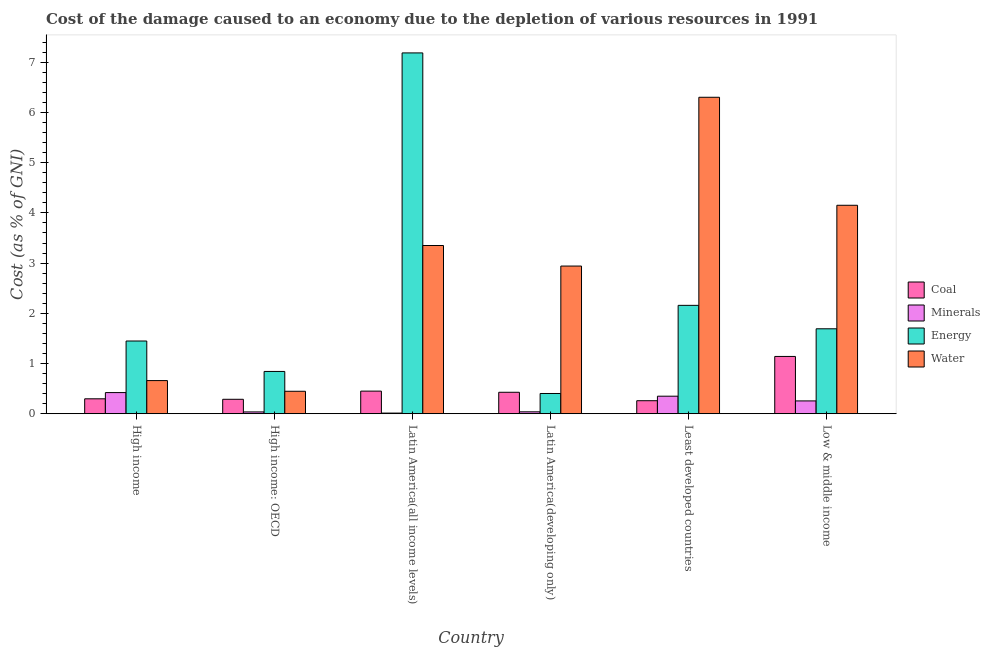Are the number of bars per tick equal to the number of legend labels?
Provide a succinct answer. Yes. How many bars are there on the 4th tick from the right?
Your answer should be very brief. 4. In how many cases, is the number of bars for a given country not equal to the number of legend labels?
Give a very brief answer. 0. What is the cost of damage due to depletion of energy in Least developed countries?
Give a very brief answer. 2.16. Across all countries, what is the maximum cost of damage due to depletion of minerals?
Keep it short and to the point. 0.42. Across all countries, what is the minimum cost of damage due to depletion of minerals?
Your answer should be compact. 0.01. In which country was the cost of damage due to depletion of coal maximum?
Offer a terse response. Low & middle income. In which country was the cost of damage due to depletion of water minimum?
Offer a very short reply. High income: OECD. What is the total cost of damage due to depletion of water in the graph?
Your answer should be very brief. 17.85. What is the difference between the cost of damage due to depletion of coal in High income: OECD and that in Latin America(developing only)?
Keep it short and to the point. -0.14. What is the difference between the cost of damage due to depletion of minerals in Low & middle income and the cost of damage due to depletion of water in Least developed countries?
Provide a short and direct response. -6.05. What is the average cost of damage due to depletion of energy per country?
Offer a very short reply. 2.29. What is the difference between the cost of damage due to depletion of coal and cost of damage due to depletion of energy in Latin America(all income levels)?
Provide a short and direct response. -6.73. What is the ratio of the cost of damage due to depletion of minerals in High income to that in Latin America(all income levels)?
Make the answer very short. 32.36. Is the cost of damage due to depletion of minerals in High income: OECD less than that in Low & middle income?
Ensure brevity in your answer.  Yes. What is the difference between the highest and the second highest cost of damage due to depletion of energy?
Ensure brevity in your answer.  5.03. What is the difference between the highest and the lowest cost of damage due to depletion of water?
Your response must be concise. 5.85. In how many countries, is the cost of damage due to depletion of water greater than the average cost of damage due to depletion of water taken over all countries?
Your answer should be compact. 3. Is it the case that in every country, the sum of the cost of damage due to depletion of energy and cost of damage due to depletion of minerals is greater than the sum of cost of damage due to depletion of water and cost of damage due to depletion of coal?
Give a very brief answer. Yes. What does the 3rd bar from the left in Low & middle income represents?
Give a very brief answer. Energy. What does the 1st bar from the right in Latin America(developing only) represents?
Ensure brevity in your answer.  Water. Is it the case that in every country, the sum of the cost of damage due to depletion of coal and cost of damage due to depletion of minerals is greater than the cost of damage due to depletion of energy?
Offer a very short reply. No. Are all the bars in the graph horizontal?
Offer a very short reply. No. Are the values on the major ticks of Y-axis written in scientific E-notation?
Your response must be concise. No. Does the graph contain any zero values?
Provide a succinct answer. No. Where does the legend appear in the graph?
Provide a succinct answer. Center right. How are the legend labels stacked?
Offer a very short reply. Vertical. What is the title of the graph?
Your response must be concise. Cost of the damage caused to an economy due to the depletion of various resources in 1991 . Does "Insurance services" appear as one of the legend labels in the graph?
Give a very brief answer. No. What is the label or title of the X-axis?
Offer a very short reply. Country. What is the label or title of the Y-axis?
Offer a terse response. Cost (as % of GNI). What is the Cost (as % of GNI) in Coal in High income?
Keep it short and to the point. 0.3. What is the Cost (as % of GNI) of Minerals in High income?
Keep it short and to the point. 0.42. What is the Cost (as % of GNI) of Energy in High income?
Make the answer very short. 1.45. What is the Cost (as % of GNI) of Water in High income?
Your answer should be very brief. 0.66. What is the Cost (as % of GNI) of Coal in High income: OECD?
Make the answer very short. 0.29. What is the Cost (as % of GNI) of Minerals in High income: OECD?
Your answer should be very brief. 0.04. What is the Cost (as % of GNI) in Energy in High income: OECD?
Offer a terse response. 0.84. What is the Cost (as % of GNI) in Water in High income: OECD?
Your answer should be very brief. 0.45. What is the Cost (as % of GNI) in Coal in Latin America(all income levels)?
Ensure brevity in your answer.  0.45. What is the Cost (as % of GNI) in Minerals in Latin America(all income levels)?
Provide a succinct answer. 0.01. What is the Cost (as % of GNI) in Energy in Latin America(all income levels)?
Provide a succinct answer. 7.19. What is the Cost (as % of GNI) in Water in Latin America(all income levels)?
Offer a terse response. 3.35. What is the Cost (as % of GNI) in Coal in Latin America(developing only)?
Your answer should be compact. 0.43. What is the Cost (as % of GNI) of Minerals in Latin America(developing only)?
Make the answer very short. 0.04. What is the Cost (as % of GNI) in Energy in Latin America(developing only)?
Provide a succinct answer. 0.4. What is the Cost (as % of GNI) of Water in Latin America(developing only)?
Your answer should be compact. 2.94. What is the Cost (as % of GNI) in Coal in Least developed countries?
Offer a terse response. 0.26. What is the Cost (as % of GNI) in Minerals in Least developed countries?
Provide a succinct answer. 0.35. What is the Cost (as % of GNI) of Energy in Least developed countries?
Offer a terse response. 2.16. What is the Cost (as % of GNI) in Water in Least developed countries?
Provide a short and direct response. 6.3. What is the Cost (as % of GNI) of Coal in Low & middle income?
Keep it short and to the point. 1.14. What is the Cost (as % of GNI) of Minerals in Low & middle income?
Offer a terse response. 0.26. What is the Cost (as % of GNI) of Energy in Low & middle income?
Your answer should be very brief. 1.69. What is the Cost (as % of GNI) of Water in Low & middle income?
Offer a very short reply. 4.15. Across all countries, what is the maximum Cost (as % of GNI) of Coal?
Offer a terse response. 1.14. Across all countries, what is the maximum Cost (as % of GNI) of Minerals?
Your answer should be very brief. 0.42. Across all countries, what is the maximum Cost (as % of GNI) of Energy?
Provide a succinct answer. 7.19. Across all countries, what is the maximum Cost (as % of GNI) in Water?
Offer a very short reply. 6.3. Across all countries, what is the minimum Cost (as % of GNI) of Coal?
Offer a very short reply. 0.26. Across all countries, what is the minimum Cost (as % of GNI) in Minerals?
Offer a terse response. 0.01. Across all countries, what is the minimum Cost (as % of GNI) of Energy?
Your answer should be very brief. 0.4. Across all countries, what is the minimum Cost (as % of GNI) in Water?
Ensure brevity in your answer.  0.45. What is the total Cost (as % of GNI) in Coal in the graph?
Make the answer very short. 2.86. What is the total Cost (as % of GNI) in Minerals in the graph?
Offer a terse response. 1.11. What is the total Cost (as % of GNI) of Energy in the graph?
Give a very brief answer. 13.73. What is the total Cost (as % of GNI) of Water in the graph?
Your answer should be compact. 17.85. What is the difference between the Cost (as % of GNI) of Coal in High income and that in High income: OECD?
Ensure brevity in your answer.  0.01. What is the difference between the Cost (as % of GNI) in Minerals in High income and that in High income: OECD?
Make the answer very short. 0.38. What is the difference between the Cost (as % of GNI) of Energy in High income and that in High income: OECD?
Keep it short and to the point. 0.61. What is the difference between the Cost (as % of GNI) of Water in High income and that in High income: OECD?
Give a very brief answer. 0.21. What is the difference between the Cost (as % of GNI) in Coal in High income and that in Latin America(all income levels)?
Your response must be concise. -0.15. What is the difference between the Cost (as % of GNI) of Minerals in High income and that in Latin America(all income levels)?
Your answer should be very brief. 0.41. What is the difference between the Cost (as % of GNI) of Energy in High income and that in Latin America(all income levels)?
Keep it short and to the point. -5.74. What is the difference between the Cost (as % of GNI) of Water in High income and that in Latin America(all income levels)?
Keep it short and to the point. -2.69. What is the difference between the Cost (as % of GNI) in Coal in High income and that in Latin America(developing only)?
Keep it short and to the point. -0.13. What is the difference between the Cost (as % of GNI) in Minerals in High income and that in Latin America(developing only)?
Your answer should be very brief. 0.38. What is the difference between the Cost (as % of GNI) in Energy in High income and that in Latin America(developing only)?
Give a very brief answer. 1.05. What is the difference between the Cost (as % of GNI) in Water in High income and that in Latin America(developing only)?
Provide a succinct answer. -2.28. What is the difference between the Cost (as % of GNI) in Coal in High income and that in Least developed countries?
Offer a terse response. 0.04. What is the difference between the Cost (as % of GNI) of Minerals in High income and that in Least developed countries?
Your answer should be very brief. 0.07. What is the difference between the Cost (as % of GNI) of Energy in High income and that in Least developed countries?
Ensure brevity in your answer.  -0.71. What is the difference between the Cost (as % of GNI) in Water in High income and that in Least developed countries?
Ensure brevity in your answer.  -5.64. What is the difference between the Cost (as % of GNI) in Coal in High income and that in Low & middle income?
Give a very brief answer. -0.84. What is the difference between the Cost (as % of GNI) of Minerals in High income and that in Low & middle income?
Your response must be concise. 0.17. What is the difference between the Cost (as % of GNI) in Energy in High income and that in Low & middle income?
Provide a short and direct response. -0.24. What is the difference between the Cost (as % of GNI) of Water in High income and that in Low & middle income?
Your answer should be very brief. -3.49. What is the difference between the Cost (as % of GNI) in Coal in High income: OECD and that in Latin America(all income levels)?
Your response must be concise. -0.16. What is the difference between the Cost (as % of GNI) in Minerals in High income: OECD and that in Latin America(all income levels)?
Make the answer very short. 0.02. What is the difference between the Cost (as % of GNI) of Energy in High income: OECD and that in Latin America(all income levels)?
Your response must be concise. -6.34. What is the difference between the Cost (as % of GNI) in Water in High income: OECD and that in Latin America(all income levels)?
Make the answer very short. -2.9. What is the difference between the Cost (as % of GNI) in Coal in High income: OECD and that in Latin America(developing only)?
Your answer should be compact. -0.14. What is the difference between the Cost (as % of GNI) of Minerals in High income: OECD and that in Latin America(developing only)?
Provide a short and direct response. -0. What is the difference between the Cost (as % of GNI) in Energy in High income: OECD and that in Latin America(developing only)?
Your answer should be very brief. 0.44. What is the difference between the Cost (as % of GNI) of Water in High income: OECD and that in Latin America(developing only)?
Your answer should be very brief. -2.49. What is the difference between the Cost (as % of GNI) of Coal in High income: OECD and that in Least developed countries?
Your answer should be compact. 0.03. What is the difference between the Cost (as % of GNI) in Minerals in High income: OECD and that in Least developed countries?
Give a very brief answer. -0.31. What is the difference between the Cost (as % of GNI) of Energy in High income: OECD and that in Least developed countries?
Provide a succinct answer. -1.32. What is the difference between the Cost (as % of GNI) in Water in High income: OECD and that in Least developed countries?
Your response must be concise. -5.85. What is the difference between the Cost (as % of GNI) of Coal in High income: OECD and that in Low & middle income?
Give a very brief answer. -0.85. What is the difference between the Cost (as % of GNI) of Minerals in High income: OECD and that in Low & middle income?
Your response must be concise. -0.22. What is the difference between the Cost (as % of GNI) in Energy in High income: OECD and that in Low & middle income?
Provide a succinct answer. -0.85. What is the difference between the Cost (as % of GNI) of Water in High income: OECD and that in Low & middle income?
Your answer should be compact. -3.7. What is the difference between the Cost (as % of GNI) of Coal in Latin America(all income levels) and that in Latin America(developing only)?
Ensure brevity in your answer.  0.02. What is the difference between the Cost (as % of GNI) in Minerals in Latin America(all income levels) and that in Latin America(developing only)?
Provide a succinct answer. -0.03. What is the difference between the Cost (as % of GNI) in Energy in Latin America(all income levels) and that in Latin America(developing only)?
Your answer should be very brief. 6.78. What is the difference between the Cost (as % of GNI) of Water in Latin America(all income levels) and that in Latin America(developing only)?
Your answer should be compact. 0.41. What is the difference between the Cost (as % of GNI) in Coal in Latin America(all income levels) and that in Least developed countries?
Give a very brief answer. 0.19. What is the difference between the Cost (as % of GNI) of Minerals in Latin America(all income levels) and that in Least developed countries?
Give a very brief answer. -0.34. What is the difference between the Cost (as % of GNI) in Energy in Latin America(all income levels) and that in Least developed countries?
Provide a succinct answer. 5.03. What is the difference between the Cost (as % of GNI) of Water in Latin America(all income levels) and that in Least developed countries?
Your answer should be very brief. -2.95. What is the difference between the Cost (as % of GNI) in Coal in Latin America(all income levels) and that in Low & middle income?
Offer a terse response. -0.69. What is the difference between the Cost (as % of GNI) in Minerals in Latin America(all income levels) and that in Low & middle income?
Give a very brief answer. -0.24. What is the difference between the Cost (as % of GNI) in Energy in Latin America(all income levels) and that in Low & middle income?
Give a very brief answer. 5.49. What is the difference between the Cost (as % of GNI) of Water in Latin America(all income levels) and that in Low & middle income?
Your answer should be compact. -0.8. What is the difference between the Cost (as % of GNI) in Coal in Latin America(developing only) and that in Least developed countries?
Keep it short and to the point. 0.17. What is the difference between the Cost (as % of GNI) of Minerals in Latin America(developing only) and that in Least developed countries?
Offer a very short reply. -0.31. What is the difference between the Cost (as % of GNI) in Energy in Latin America(developing only) and that in Least developed countries?
Provide a short and direct response. -1.76. What is the difference between the Cost (as % of GNI) in Water in Latin America(developing only) and that in Least developed countries?
Offer a very short reply. -3.36. What is the difference between the Cost (as % of GNI) of Coal in Latin America(developing only) and that in Low & middle income?
Your answer should be compact. -0.71. What is the difference between the Cost (as % of GNI) in Minerals in Latin America(developing only) and that in Low & middle income?
Offer a very short reply. -0.22. What is the difference between the Cost (as % of GNI) in Energy in Latin America(developing only) and that in Low & middle income?
Your response must be concise. -1.29. What is the difference between the Cost (as % of GNI) of Water in Latin America(developing only) and that in Low & middle income?
Ensure brevity in your answer.  -1.21. What is the difference between the Cost (as % of GNI) in Coal in Least developed countries and that in Low & middle income?
Make the answer very short. -0.88. What is the difference between the Cost (as % of GNI) of Minerals in Least developed countries and that in Low & middle income?
Offer a very short reply. 0.09. What is the difference between the Cost (as % of GNI) of Energy in Least developed countries and that in Low & middle income?
Offer a very short reply. 0.47. What is the difference between the Cost (as % of GNI) in Water in Least developed countries and that in Low & middle income?
Your answer should be very brief. 2.15. What is the difference between the Cost (as % of GNI) of Coal in High income and the Cost (as % of GNI) of Minerals in High income: OECD?
Make the answer very short. 0.26. What is the difference between the Cost (as % of GNI) of Coal in High income and the Cost (as % of GNI) of Energy in High income: OECD?
Provide a succinct answer. -0.55. What is the difference between the Cost (as % of GNI) in Coal in High income and the Cost (as % of GNI) in Water in High income: OECD?
Ensure brevity in your answer.  -0.15. What is the difference between the Cost (as % of GNI) of Minerals in High income and the Cost (as % of GNI) of Energy in High income: OECD?
Your answer should be very brief. -0.42. What is the difference between the Cost (as % of GNI) in Minerals in High income and the Cost (as % of GNI) in Water in High income: OECD?
Your answer should be very brief. -0.03. What is the difference between the Cost (as % of GNI) of Coal in High income and the Cost (as % of GNI) of Minerals in Latin America(all income levels)?
Give a very brief answer. 0.28. What is the difference between the Cost (as % of GNI) of Coal in High income and the Cost (as % of GNI) of Energy in Latin America(all income levels)?
Offer a terse response. -6.89. What is the difference between the Cost (as % of GNI) in Coal in High income and the Cost (as % of GNI) in Water in Latin America(all income levels)?
Offer a very short reply. -3.05. What is the difference between the Cost (as % of GNI) of Minerals in High income and the Cost (as % of GNI) of Energy in Latin America(all income levels)?
Your answer should be compact. -6.76. What is the difference between the Cost (as % of GNI) of Minerals in High income and the Cost (as % of GNI) of Water in Latin America(all income levels)?
Keep it short and to the point. -2.93. What is the difference between the Cost (as % of GNI) of Energy in High income and the Cost (as % of GNI) of Water in Latin America(all income levels)?
Your answer should be very brief. -1.9. What is the difference between the Cost (as % of GNI) of Coal in High income and the Cost (as % of GNI) of Minerals in Latin America(developing only)?
Give a very brief answer. 0.26. What is the difference between the Cost (as % of GNI) in Coal in High income and the Cost (as % of GNI) in Energy in Latin America(developing only)?
Your answer should be very brief. -0.11. What is the difference between the Cost (as % of GNI) of Coal in High income and the Cost (as % of GNI) of Water in Latin America(developing only)?
Offer a very short reply. -2.64. What is the difference between the Cost (as % of GNI) in Minerals in High income and the Cost (as % of GNI) in Energy in Latin America(developing only)?
Your response must be concise. 0.02. What is the difference between the Cost (as % of GNI) of Minerals in High income and the Cost (as % of GNI) of Water in Latin America(developing only)?
Your answer should be very brief. -2.52. What is the difference between the Cost (as % of GNI) in Energy in High income and the Cost (as % of GNI) in Water in Latin America(developing only)?
Your answer should be very brief. -1.49. What is the difference between the Cost (as % of GNI) of Coal in High income and the Cost (as % of GNI) of Minerals in Least developed countries?
Provide a succinct answer. -0.05. What is the difference between the Cost (as % of GNI) in Coal in High income and the Cost (as % of GNI) in Energy in Least developed countries?
Your response must be concise. -1.86. What is the difference between the Cost (as % of GNI) of Coal in High income and the Cost (as % of GNI) of Water in Least developed countries?
Provide a succinct answer. -6. What is the difference between the Cost (as % of GNI) of Minerals in High income and the Cost (as % of GNI) of Energy in Least developed countries?
Offer a terse response. -1.74. What is the difference between the Cost (as % of GNI) of Minerals in High income and the Cost (as % of GNI) of Water in Least developed countries?
Your response must be concise. -5.88. What is the difference between the Cost (as % of GNI) of Energy in High income and the Cost (as % of GNI) of Water in Least developed countries?
Offer a very short reply. -4.85. What is the difference between the Cost (as % of GNI) in Coal in High income and the Cost (as % of GNI) in Minerals in Low & middle income?
Make the answer very short. 0.04. What is the difference between the Cost (as % of GNI) in Coal in High income and the Cost (as % of GNI) in Energy in Low & middle income?
Make the answer very short. -1.39. What is the difference between the Cost (as % of GNI) of Coal in High income and the Cost (as % of GNI) of Water in Low & middle income?
Your answer should be very brief. -3.85. What is the difference between the Cost (as % of GNI) of Minerals in High income and the Cost (as % of GNI) of Energy in Low & middle income?
Offer a very short reply. -1.27. What is the difference between the Cost (as % of GNI) of Minerals in High income and the Cost (as % of GNI) of Water in Low & middle income?
Make the answer very short. -3.73. What is the difference between the Cost (as % of GNI) in Energy in High income and the Cost (as % of GNI) in Water in Low & middle income?
Offer a very short reply. -2.7. What is the difference between the Cost (as % of GNI) in Coal in High income: OECD and the Cost (as % of GNI) in Minerals in Latin America(all income levels)?
Make the answer very short. 0.27. What is the difference between the Cost (as % of GNI) in Coal in High income: OECD and the Cost (as % of GNI) in Energy in Latin America(all income levels)?
Provide a succinct answer. -6.9. What is the difference between the Cost (as % of GNI) in Coal in High income: OECD and the Cost (as % of GNI) in Water in Latin America(all income levels)?
Offer a very short reply. -3.06. What is the difference between the Cost (as % of GNI) of Minerals in High income: OECD and the Cost (as % of GNI) of Energy in Latin America(all income levels)?
Provide a succinct answer. -7.15. What is the difference between the Cost (as % of GNI) in Minerals in High income: OECD and the Cost (as % of GNI) in Water in Latin America(all income levels)?
Give a very brief answer. -3.31. What is the difference between the Cost (as % of GNI) of Energy in High income: OECD and the Cost (as % of GNI) of Water in Latin America(all income levels)?
Ensure brevity in your answer.  -2.51. What is the difference between the Cost (as % of GNI) of Coal in High income: OECD and the Cost (as % of GNI) of Minerals in Latin America(developing only)?
Give a very brief answer. 0.25. What is the difference between the Cost (as % of GNI) in Coal in High income: OECD and the Cost (as % of GNI) in Energy in Latin America(developing only)?
Your answer should be very brief. -0.12. What is the difference between the Cost (as % of GNI) of Coal in High income: OECD and the Cost (as % of GNI) of Water in Latin America(developing only)?
Provide a succinct answer. -2.65. What is the difference between the Cost (as % of GNI) of Minerals in High income: OECD and the Cost (as % of GNI) of Energy in Latin America(developing only)?
Your answer should be very brief. -0.37. What is the difference between the Cost (as % of GNI) in Minerals in High income: OECD and the Cost (as % of GNI) in Water in Latin America(developing only)?
Keep it short and to the point. -2.9. What is the difference between the Cost (as % of GNI) in Energy in High income: OECD and the Cost (as % of GNI) in Water in Latin America(developing only)?
Keep it short and to the point. -2.1. What is the difference between the Cost (as % of GNI) in Coal in High income: OECD and the Cost (as % of GNI) in Minerals in Least developed countries?
Your answer should be compact. -0.06. What is the difference between the Cost (as % of GNI) of Coal in High income: OECD and the Cost (as % of GNI) of Energy in Least developed countries?
Provide a short and direct response. -1.87. What is the difference between the Cost (as % of GNI) in Coal in High income: OECD and the Cost (as % of GNI) in Water in Least developed countries?
Offer a terse response. -6.01. What is the difference between the Cost (as % of GNI) in Minerals in High income: OECD and the Cost (as % of GNI) in Energy in Least developed countries?
Your response must be concise. -2.12. What is the difference between the Cost (as % of GNI) of Minerals in High income: OECD and the Cost (as % of GNI) of Water in Least developed countries?
Your answer should be very brief. -6.27. What is the difference between the Cost (as % of GNI) of Energy in High income: OECD and the Cost (as % of GNI) of Water in Least developed countries?
Your answer should be compact. -5.46. What is the difference between the Cost (as % of GNI) in Coal in High income: OECD and the Cost (as % of GNI) in Minerals in Low & middle income?
Keep it short and to the point. 0.03. What is the difference between the Cost (as % of GNI) of Coal in High income: OECD and the Cost (as % of GNI) of Energy in Low & middle income?
Provide a succinct answer. -1.4. What is the difference between the Cost (as % of GNI) in Coal in High income: OECD and the Cost (as % of GNI) in Water in Low & middle income?
Provide a succinct answer. -3.86. What is the difference between the Cost (as % of GNI) of Minerals in High income: OECD and the Cost (as % of GNI) of Energy in Low & middle income?
Your answer should be compact. -1.66. What is the difference between the Cost (as % of GNI) in Minerals in High income: OECD and the Cost (as % of GNI) in Water in Low & middle income?
Offer a terse response. -4.11. What is the difference between the Cost (as % of GNI) in Energy in High income: OECD and the Cost (as % of GNI) in Water in Low & middle income?
Your answer should be compact. -3.31. What is the difference between the Cost (as % of GNI) of Coal in Latin America(all income levels) and the Cost (as % of GNI) of Minerals in Latin America(developing only)?
Make the answer very short. 0.41. What is the difference between the Cost (as % of GNI) of Coal in Latin America(all income levels) and the Cost (as % of GNI) of Energy in Latin America(developing only)?
Provide a short and direct response. 0.05. What is the difference between the Cost (as % of GNI) in Coal in Latin America(all income levels) and the Cost (as % of GNI) in Water in Latin America(developing only)?
Keep it short and to the point. -2.49. What is the difference between the Cost (as % of GNI) of Minerals in Latin America(all income levels) and the Cost (as % of GNI) of Energy in Latin America(developing only)?
Your response must be concise. -0.39. What is the difference between the Cost (as % of GNI) in Minerals in Latin America(all income levels) and the Cost (as % of GNI) in Water in Latin America(developing only)?
Offer a terse response. -2.93. What is the difference between the Cost (as % of GNI) of Energy in Latin America(all income levels) and the Cost (as % of GNI) of Water in Latin America(developing only)?
Make the answer very short. 4.24. What is the difference between the Cost (as % of GNI) of Coal in Latin America(all income levels) and the Cost (as % of GNI) of Minerals in Least developed countries?
Your answer should be compact. 0.1. What is the difference between the Cost (as % of GNI) of Coal in Latin America(all income levels) and the Cost (as % of GNI) of Energy in Least developed countries?
Your answer should be compact. -1.71. What is the difference between the Cost (as % of GNI) of Coal in Latin America(all income levels) and the Cost (as % of GNI) of Water in Least developed countries?
Your answer should be compact. -5.85. What is the difference between the Cost (as % of GNI) of Minerals in Latin America(all income levels) and the Cost (as % of GNI) of Energy in Least developed countries?
Give a very brief answer. -2.15. What is the difference between the Cost (as % of GNI) in Minerals in Latin America(all income levels) and the Cost (as % of GNI) in Water in Least developed countries?
Offer a terse response. -6.29. What is the difference between the Cost (as % of GNI) in Energy in Latin America(all income levels) and the Cost (as % of GNI) in Water in Least developed countries?
Your answer should be compact. 0.88. What is the difference between the Cost (as % of GNI) of Coal in Latin America(all income levels) and the Cost (as % of GNI) of Minerals in Low & middle income?
Your answer should be very brief. 0.2. What is the difference between the Cost (as % of GNI) of Coal in Latin America(all income levels) and the Cost (as % of GNI) of Energy in Low & middle income?
Provide a succinct answer. -1.24. What is the difference between the Cost (as % of GNI) in Coal in Latin America(all income levels) and the Cost (as % of GNI) in Water in Low & middle income?
Your response must be concise. -3.7. What is the difference between the Cost (as % of GNI) in Minerals in Latin America(all income levels) and the Cost (as % of GNI) in Energy in Low & middle income?
Ensure brevity in your answer.  -1.68. What is the difference between the Cost (as % of GNI) of Minerals in Latin America(all income levels) and the Cost (as % of GNI) of Water in Low & middle income?
Give a very brief answer. -4.14. What is the difference between the Cost (as % of GNI) of Energy in Latin America(all income levels) and the Cost (as % of GNI) of Water in Low & middle income?
Provide a short and direct response. 3.03. What is the difference between the Cost (as % of GNI) in Coal in Latin America(developing only) and the Cost (as % of GNI) in Minerals in Least developed countries?
Provide a short and direct response. 0.08. What is the difference between the Cost (as % of GNI) in Coal in Latin America(developing only) and the Cost (as % of GNI) in Energy in Least developed countries?
Make the answer very short. -1.73. What is the difference between the Cost (as % of GNI) in Coal in Latin America(developing only) and the Cost (as % of GNI) in Water in Least developed countries?
Give a very brief answer. -5.87. What is the difference between the Cost (as % of GNI) of Minerals in Latin America(developing only) and the Cost (as % of GNI) of Energy in Least developed countries?
Provide a short and direct response. -2.12. What is the difference between the Cost (as % of GNI) in Minerals in Latin America(developing only) and the Cost (as % of GNI) in Water in Least developed countries?
Offer a terse response. -6.26. What is the difference between the Cost (as % of GNI) of Energy in Latin America(developing only) and the Cost (as % of GNI) of Water in Least developed countries?
Offer a terse response. -5.9. What is the difference between the Cost (as % of GNI) in Coal in Latin America(developing only) and the Cost (as % of GNI) in Minerals in Low & middle income?
Your answer should be very brief. 0.17. What is the difference between the Cost (as % of GNI) in Coal in Latin America(developing only) and the Cost (as % of GNI) in Energy in Low & middle income?
Offer a terse response. -1.26. What is the difference between the Cost (as % of GNI) in Coal in Latin America(developing only) and the Cost (as % of GNI) in Water in Low & middle income?
Give a very brief answer. -3.72. What is the difference between the Cost (as % of GNI) in Minerals in Latin America(developing only) and the Cost (as % of GNI) in Energy in Low & middle income?
Your answer should be very brief. -1.65. What is the difference between the Cost (as % of GNI) of Minerals in Latin America(developing only) and the Cost (as % of GNI) of Water in Low & middle income?
Ensure brevity in your answer.  -4.11. What is the difference between the Cost (as % of GNI) of Energy in Latin America(developing only) and the Cost (as % of GNI) of Water in Low & middle income?
Ensure brevity in your answer.  -3.75. What is the difference between the Cost (as % of GNI) in Coal in Least developed countries and the Cost (as % of GNI) in Minerals in Low & middle income?
Keep it short and to the point. 0. What is the difference between the Cost (as % of GNI) in Coal in Least developed countries and the Cost (as % of GNI) in Energy in Low & middle income?
Keep it short and to the point. -1.43. What is the difference between the Cost (as % of GNI) of Coal in Least developed countries and the Cost (as % of GNI) of Water in Low & middle income?
Ensure brevity in your answer.  -3.89. What is the difference between the Cost (as % of GNI) in Minerals in Least developed countries and the Cost (as % of GNI) in Energy in Low & middle income?
Offer a terse response. -1.34. What is the difference between the Cost (as % of GNI) of Minerals in Least developed countries and the Cost (as % of GNI) of Water in Low & middle income?
Make the answer very short. -3.8. What is the difference between the Cost (as % of GNI) in Energy in Least developed countries and the Cost (as % of GNI) in Water in Low & middle income?
Offer a terse response. -1.99. What is the average Cost (as % of GNI) of Coal per country?
Give a very brief answer. 0.48. What is the average Cost (as % of GNI) in Minerals per country?
Provide a short and direct response. 0.19. What is the average Cost (as % of GNI) of Energy per country?
Provide a short and direct response. 2.29. What is the average Cost (as % of GNI) of Water per country?
Your answer should be very brief. 2.98. What is the difference between the Cost (as % of GNI) in Coal and Cost (as % of GNI) in Minerals in High income?
Your answer should be compact. -0.12. What is the difference between the Cost (as % of GNI) in Coal and Cost (as % of GNI) in Energy in High income?
Your answer should be very brief. -1.15. What is the difference between the Cost (as % of GNI) of Coal and Cost (as % of GNI) of Water in High income?
Your answer should be compact. -0.36. What is the difference between the Cost (as % of GNI) in Minerals and Cost (as % of GNI) in Energy in High income?
Ensure brevity in your answer.  -1.03. What is the difference between the Cost (as % of GNI) in Minerals and Cost (as % of GNI) in Water in High income?
Provide a short and direct response. -0.24. What is the difference between the Cost (as % of GNI) in Energy and Cost (as % of GNI) in Water in High income?
Offer a terse response. 0.79. What is the difference between the Cost (as % of GNI) of Coal and Cost (as % of GNI) of Minerals in High income: OECD?
Offer a terse response. 0.25. What is the difference between the Cost (as % of GNI) of Coal and Cost (as % of GNI) of Energy in High income: OECD?
Keep it short and to the point. -0.55. What is the difference between the Cost (as % of GNI) in Coal and Cost (as % of GNI) in Water in High income: OECD?
Provide a short and direct response. -0.16. What is the difference between the Cost (as % of GNI) of Minerals and Cost (as % of GNI) of Energy in High income: OECD?
Your answer should be compact. -0.81. What is the difference between the Cost (as % of GNI) of Minerals and Cost (as % of GNI) of Water in High income: OECD?
Make the answer very short. -0.41. What is the difference between the Cost (as % of GNI) in Energy and Cost (as % of GNI) in Water in High income: OECD?
Offer a very short reply. 0.4. What is the difference between the Cost (as % of GNI) of Coal and Cost (as % of GNI) of Minerals in Latin America(all income levels)?
Provide a succinct answer. 0.44. What is the difference between the Cost (as % of GNI) of Coal and Cost (as % of GNI) of Energy in Latin America(all income levels)?
Offer a terse response. -6.73. What is the difference between the Cost (as % of GNI) of Coal and Cost (as % of GNI) of Water in Latin America(all income levels)?
Provide a short and direct response. -2.9. What is the difference between the Cost (as % of GNI) of Minerals and Cost (as % of GNI) of Energy in Latin America(all income levels)?
Your answer should be compact. -7.17. What is the difference between the Cost (as % of GNI) in Minerals and Cost (as % of GNI) in Water in Latin America(all income levels)?
Your answer should be compact. -3.34. What is the difference between the Cost (as % of GNI) in Energy and Cost (as % of GNI) in Water in Latin America(all income levels)?
Make the answer very short. 3.84. What is the difference between the Cost (as % of GNI) of Coal and Cost (as % of GNI) of Minerals in Latin America(developing only)?
Provide a succinct answer. 0.39. What is the difference between the Cost (as % of GNI) in Coal and Cost (as % of GNI) in Energy in Latin America(developing only)?
Provide a succinct answer. 0.02. What is the difference between the Cost (as % of GNI) in Coal and Cost (as % of GNI) in Water in Latin America(developing only)?
Give a very brief answer. -2.51. What is the difference between the Cost (as % of GNI) in Minerals and Cost (as % of GNI) in Energy in Latin America(developing only)?
Provide a short and direct response. -0.36. What is the difference between the Cost (as % of GNI) in Minerals and Cost (as % of GNI) in Water in Latin America(developing only)?
Your response must be concise. -2.9. What is the difference between the Cost (as % of GNI) in Energy and Cost (as % of GNI) in Water in Latin America(developing only)?
Ensure brevity in your answer.  -2.54. What is the difference between the Cost (as % of GNI) in Coal and Cost (as % of GNI) in Minerals in Least developed countries?
Your answer should be compact. -0.09. What is the difference between the Cost (as % of GNI) of Coal and Cost (as % of GNI) of Energy in Least developed countries?
Make the answer very short. -1.9. What is the difference between the Cost (as % of GNI) of Coal and Cost (as % of GNI) of Water in Least developed countries?
Offer a very short reply. -6.04. What is the difference between the Cost (as % of GNI) of Minerals and Cost (as % of GNI) of Energy in Least developed countries?
Offer a terse response. -1.81. What is the difference between the Cost (as % of GNI) in Minerals and Cost (as % of GNI) in Water in Least developed countries?
Provide a short and direct response. -5.95. What is the difference between the Cost (as % of GNI) in Energy and Cost (as % of GNI) in Water in Least developed countries?
Ensure brevity in your answer.  -4.14. What is the difference between the Cost (as % of GNI) of Coal and Cost (as % of GNI) of Minerals in Low & middle income?
Your response must be concise. 0.89. What is the difference between the Cost (as % of GNI) in Coal and Cost (as % of GNI) in Energy in Low & middle income?
Give a very brief answer. -0.55. What is the difference between the Cost (as % of GNI) in Coal and Cost (as % of GNI) in Water in Low & middle income?
Make the answer very short. -3.01. What is the difference between the Cost (as % of GNI) in Minerals and Cost (as % of GNI) in Energy in Low & middle income?
Offer a very short reply. -1.44. What is the difference between the Cost (as % of GNI) in Minerals and Cost (as % of GNI) in Water in Low & middle income?
Keep it short and to the point. -3.9. What is the difference between the Cost (as % of GNI) in Energy and Cost (as % of GNI) in Water in Low & middle income?
Offer a very short reply. -2.46. What is the ratio of the Cost (as % of GNI) of Coal in High income to that in High income: OECD?
Make the answer very short. 1.03. What is the ratio of the Cost (as % of GNI) in Minerals in High income to that in High income: OECD?
Offer a terse response. 11.55. What is the ratio of the Cost (as % of GNI) of Energy in High income to that in High income: OECD?
Ensure brevity in your answer.  1.72. What is the ratio of the Cost (as % of GNI) of Water in High income to that in High income: OECD?
Give a very brief answer. 1.48. What is the ratio of the Cost (as % of GNI) of Coal in High income to that in Latin America(all income levels)?
Your response must be concise. 0.66. What is the ratio of the Cost (as % of GNI) of Minerals in High income to that in Latin America(all income levels)?
Offer a terse response. 32.36. What is the ratio of the Cost (as % of GNI) in Energy in High income to that in Latin America(all income levels)?
Make the answer very short. 0.2. What is the ratio of the Cost (as % of GNI) of Water in High income to that in Latin America(all income levels)?
Your response must be concise. 0.2. What is the ratio of the Cost (as % of GNI) in Coal in High income to that in Latin America(developing only)?
Your answer should be compact. 0.7. What is the ratio of the Cost (as % of GNI) in Minerals in High income to that in Latin America(developing only)?
Provide a succinct answer. 11.06. What is the ratio of the Cost (as % of GNI) of Energy in High income to that in Latin America(developing only)?
Your answer should be very brief. 3.59. What is the ratio of the Cost (as % of GNI) of Water in High income to that in Latin America(developing only)?
Your response must be concise. 0.22. What is the ratio of the Cost (as % of GNI) of Coal in High income to that in Least developed countries?
Your response must be concise. 1.15. What is the ratio of the Cost (as % of GNI) in Minerals in High income to that in Least developed countries?
Your answer should be very brief. 1.21. What is the ratio of the Cost (as % of GNI) of Energy in High income to that in Least developed countries?
Offer a very short reply. 0.67. What is the ratio of the Cost (as % of GNI) in Water in High income to that in Least developed countries?
Offer a terse response. 0.1. What is the ratio of the Cost (as % of GNI) of Coal in High income to that in Low & middle income?
Offer a very short reply. 0.26. What is the ratio of the Cost (as % of GNI) in Minerals in High income to that in Low & middle income?
Ensure brevity in your answer.  1.65. What is the ratio of the Cost (as % of GNI) in Energy in High income to that in Low & middle income?
Ensure brevity in your answer.  0.86. What is the ratio of the Cost (as % of GNI) of Water in High income to that in Low & middle income?
Offer a terse response. 0.16. What is the ratio of the Cost (as % of GNI) in Coal in High income: OECD to that in Latin America(all income levels)?
Provide a short and direct response. 0.64. What is the ratio of the Cost (as % of GNI) in Minerals in High income: OECD to that in Latin America(all income levels)?
Your answer should be compact. 2.8. What is the ratio of the Cost (as % of GNI) of Energy in High income: OECD to that in Latin America(all income levels)?
Make the answer very short. 0.12. What is the ratio of the Cost (as % of GNI) of Water in High income: OECD to that in Latin America(all income levels)?
Your answer should be compact. 0.13. What is the ratio of the Cost (as % of GNI) in Coal in High income: OECD to that in Latin America(developing only)?
Offer a very short reply. 0.67. What is the ratio of the Cost (as % of GNI) in Minerals in High income: OECD to that in Latin America(developing only)?
Ensure brevity in your answer.  0.96. What is the ratio of the Cost (as % of GNI) of Energy in High income: OECD to that in Latin America(developing only)?
Your answer should be compact. 2.09. What is the ratio of the Cost (as % of GNI) of Water in High income: OECD to that in Latin America(developing only)?
Offer a terse response. 0.15. What is the ratio of the Cost (as % of GNI) in Coal in High income: OECD to that in Least developed countries?
Ensure brevity in your answer.  1.11. What is the ratio of the Cost (as % of GNI) of Minerals in High income: OECD to that in Least developed countries?
Offer a terse response. 0.1. What is the ratio of the Cost (as % of GNI) in Energy in High income: OECD to that in Least developed countries?
Keep it short and to the point. 0.39. What is the ratio of the Cost (as % of GNI) of Water in High income: OECD to that in Least developed countries?
Your answer should be compact. 0.07. What is the ratio of the Cost (as % of GNI) of Coal in High income: OECD to that in Low & middle income?
Your answer should be compact. 0.25. What is the ratio of the Cost (as % of GNI) of Minerals in High income: OECD to that in Low & middle income?
Offer a very short reply. 0.14. What is the ratio of the Cost (as % of GNI) of Energy in High income: OECD to that in Low & middle income?
Ensure brevity in your answer.  0.5. What is the ratio of the Cost (as % of GNI) of Water in High income: OECD to that in Low & middle income?
Keep it short and to the point. 0.11. What is the ratio of the Cost (as % of GNI) of Coal in Latin America(all income levels) to that in Latin America(developing only)?
Your response must be concise. 1.05. What is the ratio of the Cost (as % of GNI) of Minerals in Latin America(all income levels) to that in Latin America(developing only)?
Give a very brief answer. 0.34. What is the ratio of the Cost (as % of GNI) of Energy in Latin America(all income levels) to that in Latin America(developing only)?
Ensure brevity in your answer.  17.82. What is the ratio of the Cost (as % of GNI) of Water in Latin America(all income levels) to that in Latin America(developing only)?
Your response must be concise. 1.14. What is the ratio of the Cost (as % of GNI) in Coal in Latin America(all income levels) to that in Least developed countries?
Your answer should be very brief. 1.74. What is the ratio of the Cost (as % of GNI) in Minerals in Latin America(all income levels) to that in Least developed countries?
Your answer should be compact. 0.04. What is the ratio of the Cost (as % of GNI) in Energy in Latin America(all income levels) to that in Least developed countries?
Keep it short and to the point. 3.33. What is the ratio of the Cost (as % of GNI) of Water in Latin America(all income levels) to that in Least developed countries?
Keep it short and to the point. 0.53. What is the ratio of the Cost (as % of GNI) of Coal in Latin America(all income levels) to that in Low & middle income?
Offer a terse response. 0.39. What is the ratio of the Cost (as % of GNI) in Minerals in Latin America(all income levels) to that in Low & middle income?
Your response must be concise. 0.05. What is the ratio of the Cost (as % of GNI) of Energy in Latin America(all income levels) to that in Low & middle income?
Offer a very short reply. 4.25. What is the ratio of the Cost (as % of GNI) in Water in Latin America(all income levels) to that in Low & middle income?
Your answer should be very brief. 0.81. What is the ratio of the Cost (as % of GNI) in Coal in Latin America(developing only) to that in Least developed countries?
Offer a terse response. 1.65. What is the ratio of the Cost (as % of GNI) of Minerals in Latin America(developing only) to that in Least developed countries?
Offer a terse response. 0.11. What is the ratio of the Cost (as % of GNI) of Energy in Latin America(developing only) to that in Least developed countries?
Your answer should be very brief. 0.19. What is the ratio of the Cost (as % of GNI) in Water in Latin America(developing only) to that in Least developed countries?
Make the answer very short. 0.47. What is the ratio of the Cost (as % of GNI) in Coal in Latin America(developing only) to that in Low & middle income?
Give a very brief answer. 0.37. What is the ratio of the Cost (as % of GNI) of Minerals in Latin America(developing only) to that in Low & middle income?
Offer a very short reply. 0.15. What is the ratio of the Cost (as % of GNI) of Energy in Latin America(developing only) to that in Low & middle income?
Give a very brief answer. 0.24. What is the ratio of the Cost (as % of GNI) of Water in Latin America(developing only) to that in Low & middle income?
Ensure brevity in your answer.  0.71. What is the ratio of the Cost (as % of GNI) of Coal in Least developed countries to that in Low & middle income?
Your answer should be very brief. 0.23. What is the ratio of the Cost (as % of GNI) of Minerals in Least developed countries to that in Low & middle income?
Give a very brief answer. 1.37. What is the ratio of the Cost (as % of GNI) in Energy in Least developed countries to that in Low & middle income?
Your response must be concise. 1.28. What is the ratio of the Cost (as % of GNI) in Water in Least developed countries to that in Low & middle income?
Ensure brevity in your answer.  1.52. What is the difference between the highest and the second highest Cost (as % of GNI) in Coal?
Ensure brevity in your answer.  0.69. What is the difference between the highest and the second highest Cost (as % of GNI) in Minerals?
Give a very brief answer. 0.07. What is the difference between the highest and the second highest Cost (as % of GNI) of Energy?
Give a very brief answer. 5.03. What is the difference between the highest and the second highest Cost (as % of GNI) in Water?
Your response must be concise. 2.15. What is the difference between the highest and the lowest Cost (as % of GNI) of Coal?
Your response must be concise. 0.88. What is the difference between the highest and the lowest Cost (as % of GNI) of Minerals?
Provide a short and direct response. 0.41. What is the difference between the highest and the lowest Cost (as % of GNI) of Energy?
Give a very brief answer. 6.78. What is the difference between the highest and the lowest Cost (as % of GNI) in Water?
Your answer should be compact. 5.85. 